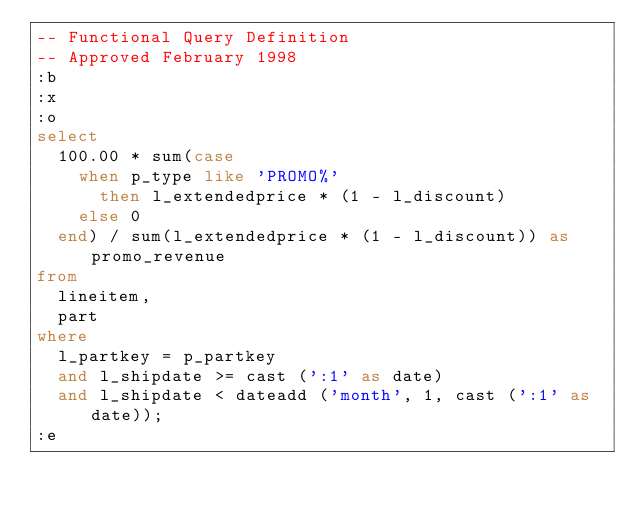Convert code to text. <code><loc_0><loc_0><loc_500><loc_500><_SQL_>-- Functional Query Definition
-- Approved February 1998
:b
:x
:o
select
	100.00 * sum(case
		when p_type like 'PROMO%'
			then l_extendedprice * (1 - l_discount)
		else 0
	end) / sum(l_extendedprice * (1 - l_discount)) as promo_revenue
from
	lineitem,
	part
where
	l_partkey = p_partkey
	and l_shipdate >= cast (':1' as date)
	and l_shipdate < dateadd ('month', 1, cast (':1' as date));
:e
</code> 